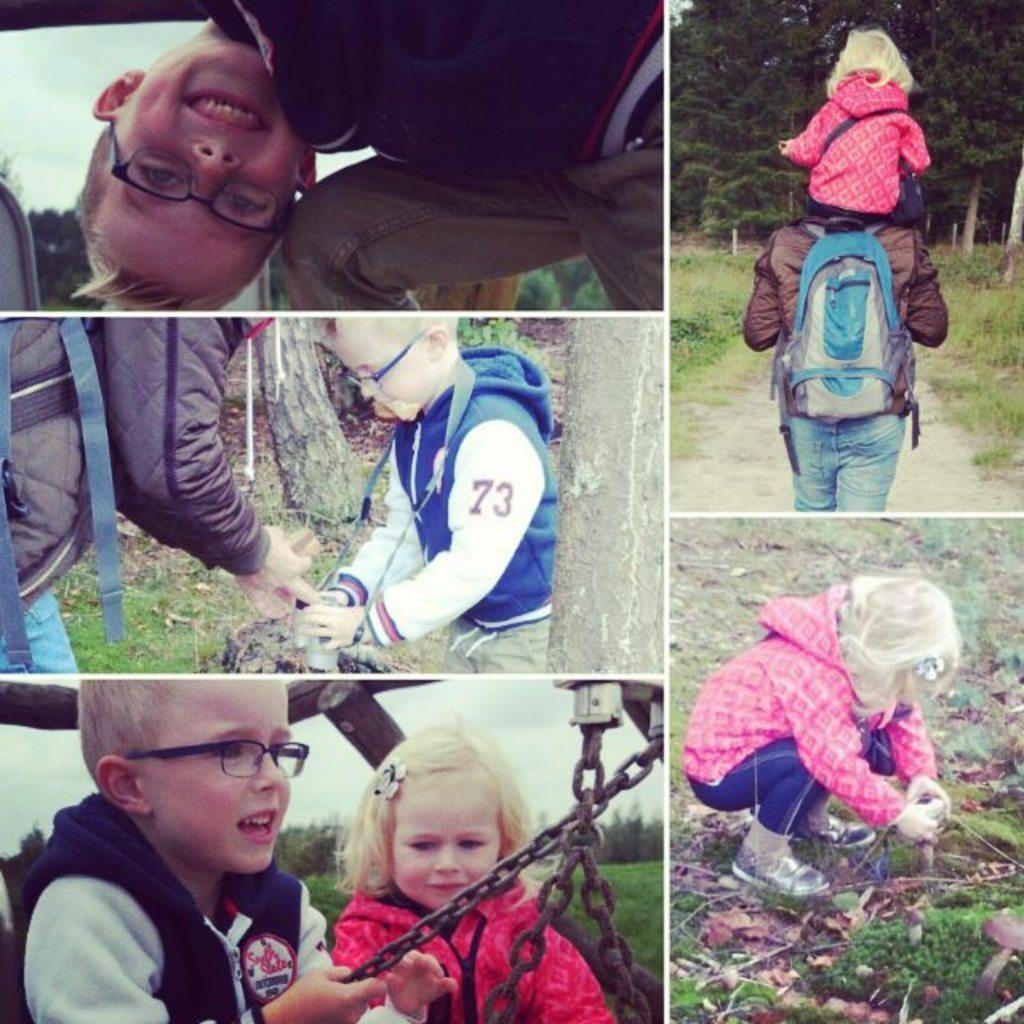In one or two sentences, can you explain what this image depicts? This image is a collage. In this image we can see people and there is grass. We can see trees. There are chains. There is sky. 